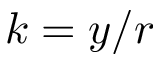Convert formula to latex. <formula><loc_0><loc_0><loc_500><loc_500>k = y / r</formula> 